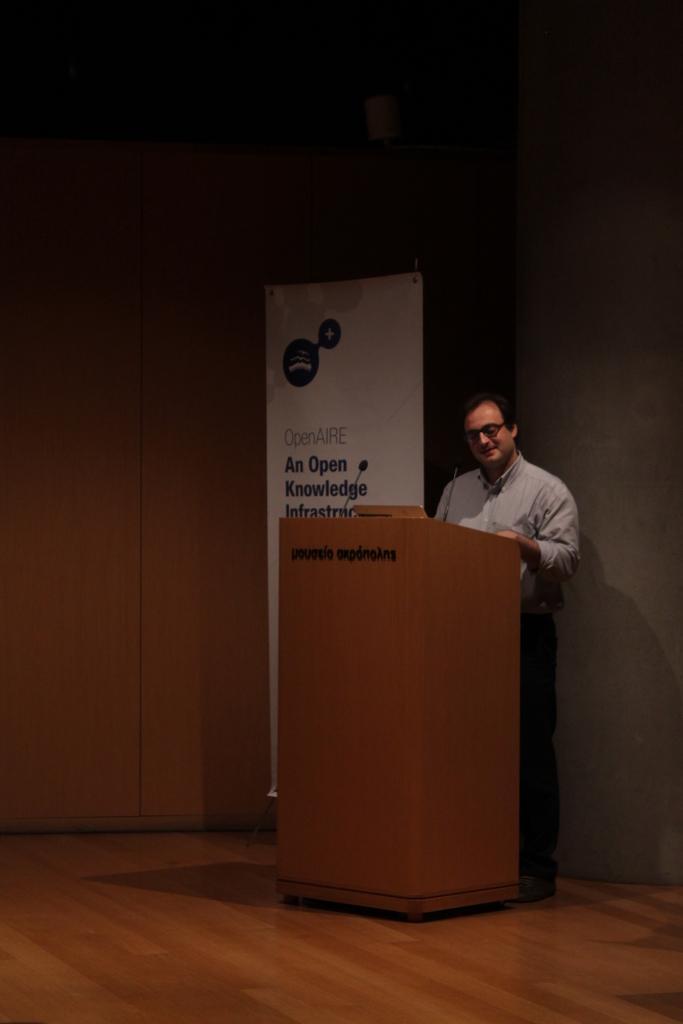Can you describe this image briefly? In this image there is a man standing. In front of him there is a podium. There is text on the podium. On the top of the podium there is a microphone. Beside him there is a banner. There is text on the banner. In the background there is a wall. At the bottom the floor is furnished with wood. 